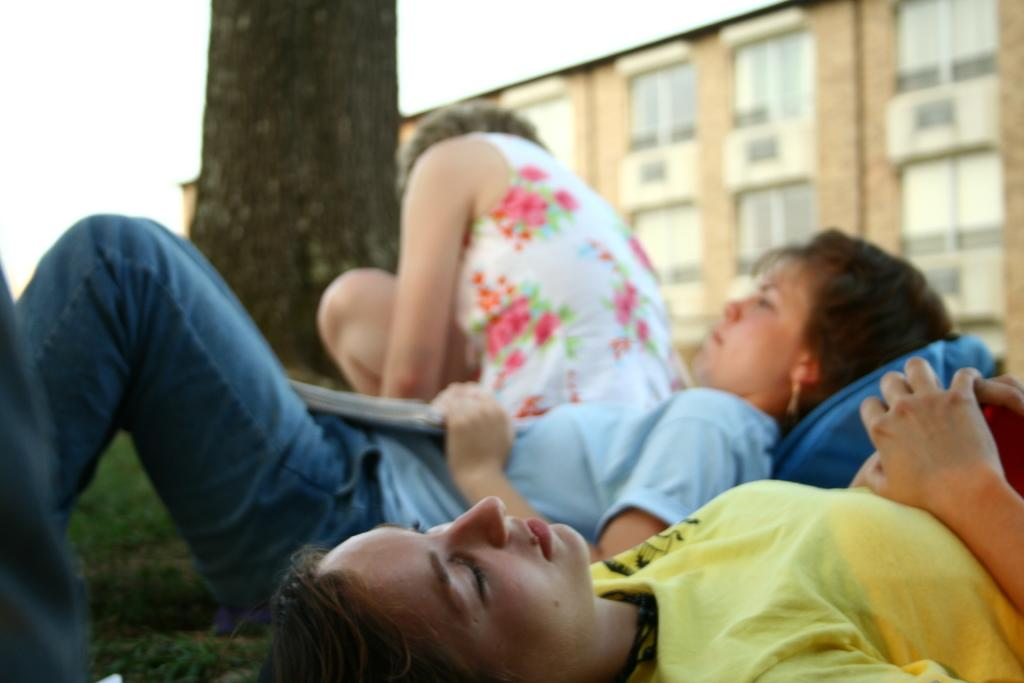What are the two people in the image doing? The two people are laying on the path. What is the position of the third person in the image? There is a person sitting in the image. What natural element can be seen in the image? There is a tree trunk visible in the image. What can be seen in the distance in the image? There is a building in the background. What is visible above the scene in the image? The sky is visible in the image. What type of celery is being used as a chess piece in the image? There is no celery or chess game present in the image. What things are being used as chess pieces in the image? There are no chess pieces or things being used as chess pieces in the image. 